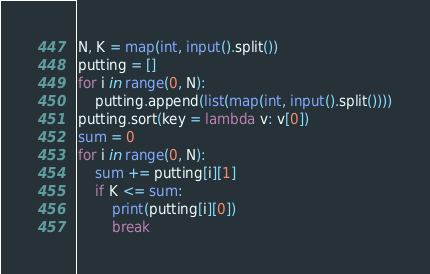<code> <loc_0><loc_0><loc_500><loc_500><_Python_>N, K = map(int, input().split())
putting = []
for i in range(0, N):
	putting.append(list(map(int, input().split())))
putting.sort(key = lambda v: v[0])
sum = 0
for i in range(0, N):
	sum += putting[i][1]
	if K <= sum:
		print(putting[i][0])
		break</code> 